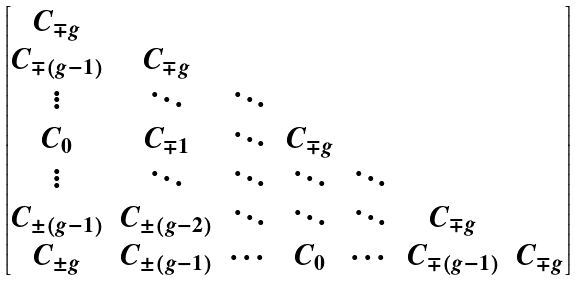Convert formula to latex. <formula><loc_0><loc_0><loc_500><loc_500>\begin{bmatrix} C _ { \mp g } & & & & & & \\ C _ { \mp ( g - 1 ) } & C _ { \mp g } & & & & & \\ \vdots & \ddots & \ddots & & & & \\ C _ { 0 } & C _ { \mp 1 } & \ddots & C _ { \mp g } & & & \\ \vdots & \ddots & \ddots & \ddots & \ddots & & \\ C _ { \pm ( g - 1 ) } & C _ { \pm ( g - 2 ) } & \ddots & \ddots & \ddots & C _ { \mp g } & \\ C _ { \pm g } & C _ { \pm ( g - 1 ) } & \cdots & C _ { 0 } & \cdots & C _ { \mp ( g - 1 ) } & C _ { \mp g } \\ \end{bmatrix}</formula> 